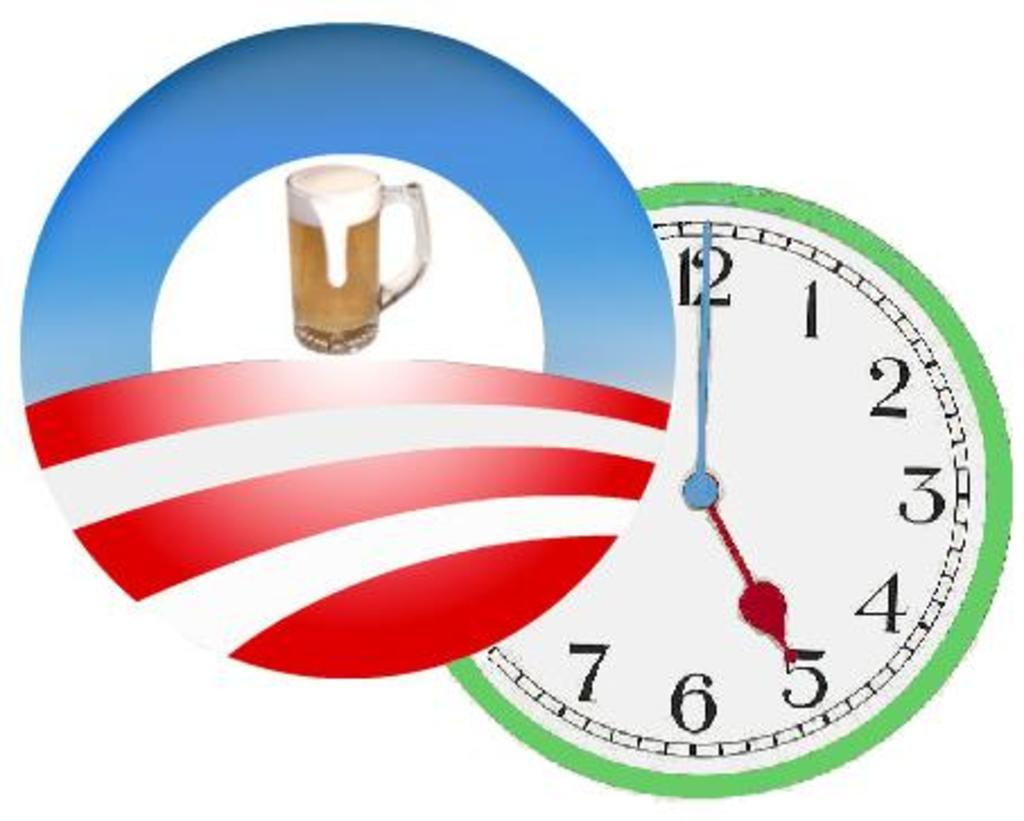<image>
Relay a brief, clear account of the picture shown. A simple beer logo states that it's 5:00. 